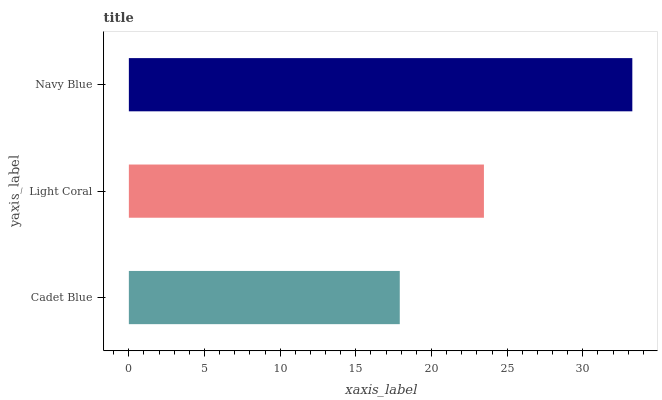Is Cadet Blue the minimum?
Answer yes or no. Yes. Is Navy Blue the maximum?
Answer yes or no. Yes. Is Light Coral the minimum?
Answer yes or no. No. Is Light Coral the maximum?
Answer yes or no. No. Is Light Coral greater than Cadet Blue?
Answer yes or no. Yes. Is Cadet Blue less than Light Coral?
Answer yes or no. Yes. Is Cadet Blue greater than Light Coral?
Answer yes or no. No. Is Light Coral less than Cadet Blue?
Answer yes or no. No. Is Light Coral the high median?
Answer yes or no. Yes. Is Light Coral the low median?
Answer yes or no. Yes. Is Cadet Blue the high median?
Answer yes or no. No. Is Cadet Blue the low median?
Answer yes or no. No. 